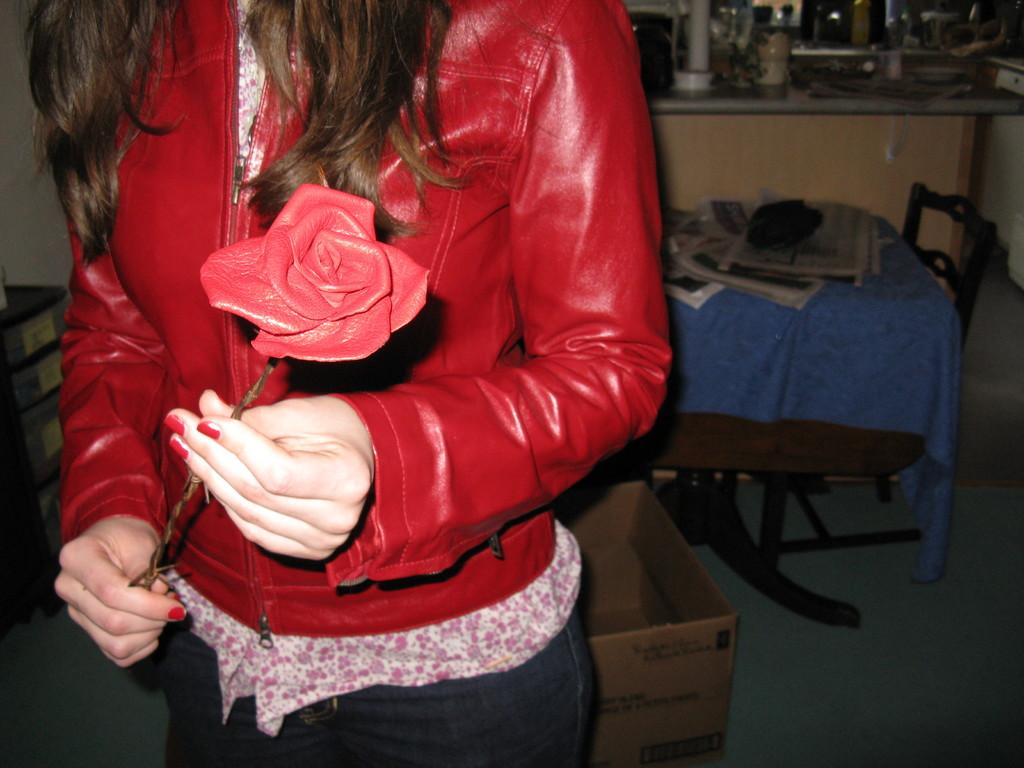What is the woman in the image wearing? The woman is wearing a red jacket in the image. What is the woman holding in the image? The woman is holding a flower in the image. What piece of furniture can be seen in the image? There is a table in the image. What items are on the table in the image? Newspapers are present on the table in the image. What object is on the floor in the image? There is a cardboard box on the floor in the image. What type of stem can be seen on the woman's jacket in the image? There is no stem visible on the woman's jacket in the image. What kind of music is the band playing in the background of the image? There is no band present in the image, so it is not possible to determine what kind of music they might be playing. 